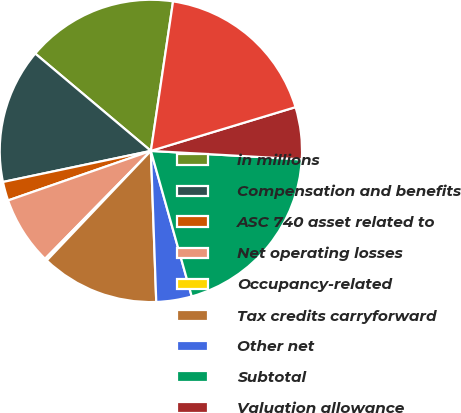Convert chart to OTSL. <chart><loc_0><loc_0><loc_500><loc_500><pie_chart><fcel>in millions<fcel>Compensation and benefits<fcel>ASC 740 asset related to<fcel>Net operating losses<fcel>Occupancy-related<fcel>Tax credits carryforward<fcel>Other net<fcel>Subtotal<fcel>Valuation allowance<fcel>Total deferred tax assets<nl><fcel>16.21%<fcel>14.43%<fcel>2.02%<fcel>7.34%<fcel>0.25%<fcel>12.66%<fcel>3.79%<fcel>19.75%<fcel>5.57%<fcel>17.98%<nl></chart> 